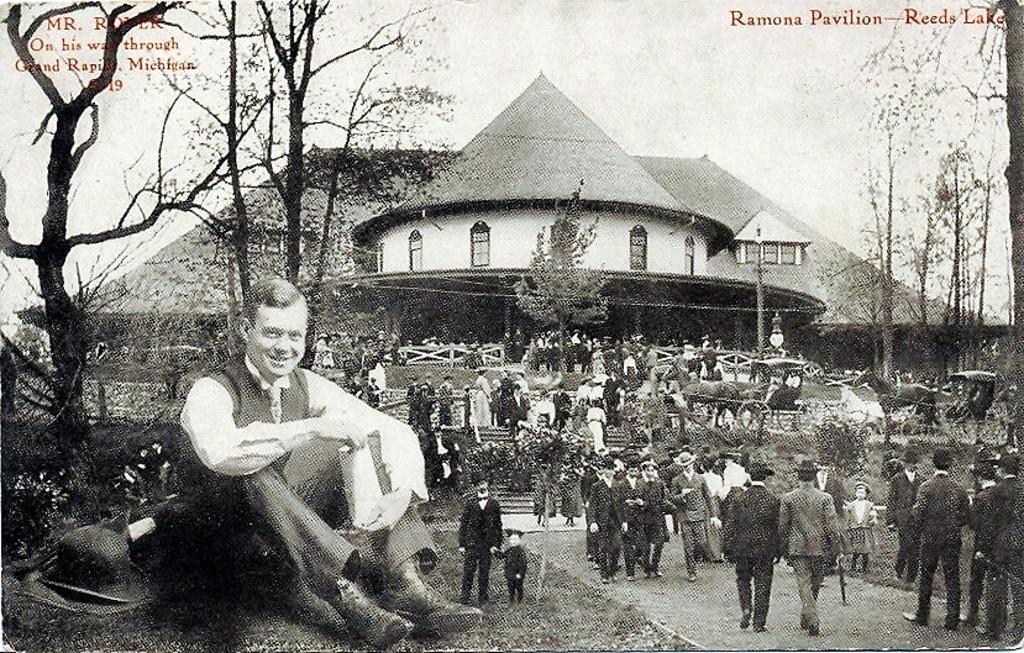How would you summarize this image in a sentence or two? To the left corner of the image there is a man sitting on the ground. Beside him there is a hat on the floor. To the right side of the image there are few people standing on the floor and also there are horse cart. In the background there is a building with walls, roofs and windows. To the right top corner of the image there is a name. 